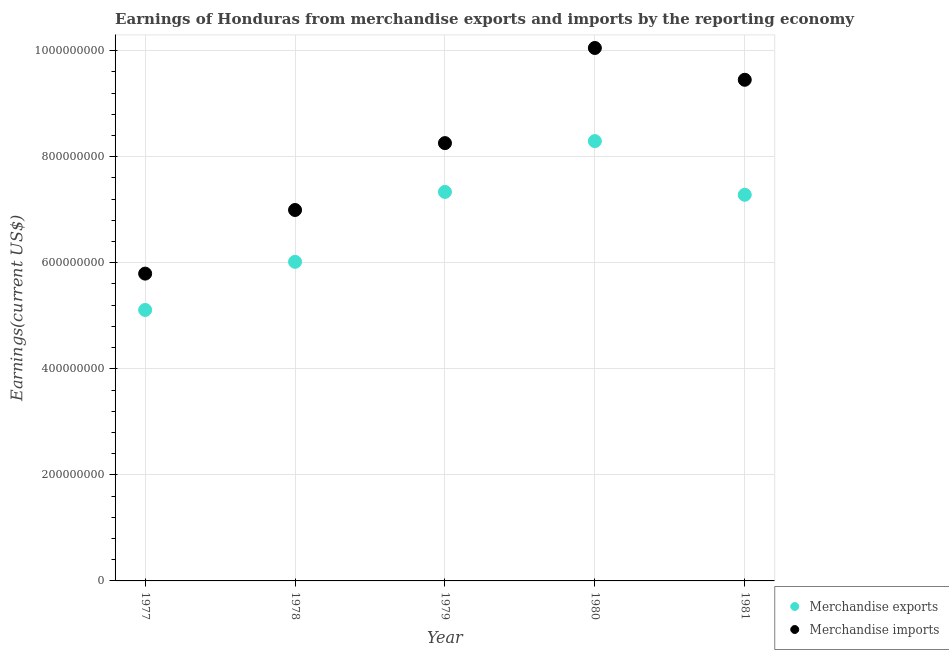Is the number of dotlines equal to the number of legend labels?
Give a very brief answer. Yes. What is the earnings from merchandise exports in 1978?
Provide a succinct answer. 6.02e+08. Across all years, what is the maximum earnings from merchandise imports?
Make the answer very short. 1.01e+09. Across all years, what is the minimum earnings from merchandise exports?
Keep it short and to the point. 5.11e+08. In which year was the earnings from merchandise imports maximum?
Offer a terse response. 1980. In which year was the earnings from merchandise exports minimum?
Your answer should be very brief. 1977. What is the total earnings from merchandise exports in the graph?
Provide a short and direct response. 3.40e+09. What is the difference between the earnings from merchandise exports in 1979 and that in 1981?
Your answer should be very brief. 5.39e+06. What is the difference between the earnings from merchandise exports in 1981 and the earnings from merchandise imports in 1980?
Provide a short and direct response. -2.77e+08. What is the average earnings from merchandise imports per year?
Make the answer very short. 8.11e+08. In the year 1981, what is the difference between the earnings from merchandise exports and earnings from merchandise imports?
Provide a short and direct response. -2.17e+08. In how many years, is the earnings from merchandise exports greater than 360000000 US$?
Make the answer very short. 5. What is the ratio of the earnings from merchandise exports in 1977 to that in 1978?
Your answer should be very brief. 0.85. Is the earnings from merchandise imports in 1980 less than that in 1981?
Provide a succinct answer. No. Is the difference between the earnings from merchandise imports in 1980 and 1981 greater than the difference between the earnings from merchandise exports in 1980 and 1981?
Your response must be concise. No. What is the difference between the highest and the second highest earnings from merchandise imports?
Provide a succinct answer. 6.00e+07. What is the difference between the highest and the lowest earnings from merchandise exports?
Your answer should be compact. 3.18e+08. In how many years, is the earnings from merchandise exports greater than the average earnings from merchandise exports taken over all years?
Offer a very short reply. 3. Is the sum of the earnings from merchandise exports in 1979 and 1980 greater than the maximum earnings from merchandise imports across all years?
Keep it short and to the point. Yes. Is the earnings from merchandise imports strictly less than the earnings from merchandise exports over the years?
Make the answer very short. No. What is the difference between two consecutive major ticks on the Y-axis?
Keep it short and to the point. 2.00e+08. Are the values on the major ticks of Y-axis written in scientific E-notation?
Make the answer very short. No. Where does the legend appear in the graph?
Provide a short and direct response. Bottom right. How many legend labels are there?
Make the answer very short. 2. How are the legend labels stacked?
Your answer should be compact. Vertical. What is the title of the graph?
Offer a terse response. Earnings of Honduras from merchandise exports and imports by the reporting economy. What is the label or title of the X-axis?
Offer a terse response. Year. What is the label or title of the Y-axis?
Provide a short and direct response. Earnings(current US$). What is the Earnings(current US$) of Merchandise exports in 1977?
Ensure brevity in your answer.  5.11e+08. What is the Earnings(current US$) in Merchandise imports in 1977?
Your response must be concise. 5.80e+08. What is the Earnings(current US$) in Merchandise exports in 1978?
Give a very brief answer. 6.02e+08. What is the Earnings(current US$) of Merchandise imports in 1978?
Make the answer very short. 7.00e+08. What is the Earnings(current US$) in Merchandise exports in 1979?
Provide a succinct answer. 7.34e+08. What is the Earnings(current US$) of Merchandise imports in 1979?
Ensure brevity in your answer.  8.26e+08. What is the Earnings(current US$) of Merchandise exports in 1980?
Your answer should be compact. 8.29e+08. What is the Earnings(current US$) in Merchandise imports in 1980?
Offer a very short reply. 1.01e+09. What is the Earnings(current US$) in Merchandise exports in 1981?
Offer a terse response. 7.28e+08. What is the Earnings(current US$) of Merchandise imports in 1981?
Make the answer very short. 9.45e+08. Across all years, what is the maximum Earnings(current US$) of Merchandise exports?
Your answer should be very brief. 8.29e+08. Across all years, what is the maximum Earnings(current US$) of Merchandise imports?
Your answer should be very brief. 1.01e+09. Across all years, what is the minimum Earnings(current US$) in Merchandise exports?
Your answer should be very brief. 5.11e+08. Across all years, what is the minimum Earnings(current US$) of Merchandise imports?
Provide a short and direct response. 5.80e+08. What is the total Earnings(current US$) of Merchandise exports in the graph?
Give a very brief answer. 3.40e+09. What is the total Earnings(current US$) in Merchandise imports in the graph?
Offer a very short reply. 4.05e+09. What is the difference between the Earnings(current US$) in Merchandise exports in 1977 and that in 1978?
Provide a short and direct response. -9.08e+07. What is the difference between the Earnings(current US$) in Merchandise imports in 1977 and that in 1978?
Ensure brevity in your answer.  -1.20e+08. What is the difference between the Earnings(current US$) in Merchandise exports in 1977 and that in 1979?
Your answer should be compact. -2.23e+08. What is the difference between the Earnings(current US$) of Merchandise imports in 1977 and that in 1979?
Provide a short and direct response. -2.46e+08. What is the difference between the Earnings(current US$) in Merchandise exports in 1977 and that in 1980?
Offer a very short reply. -3.18e+08. What is the difference between the Earnings(current US$) of Merchandise imports in 1977 and that in 1980?
Provide a short and direct response. -4.26e+08. What is the difference between the Earnings(current US$) in Merchandise exports in 1977 and that in 1981?
Make the answer very short. -2.17e+08. What is the difference between the Earnings(current US$) of Merchandise imports in 1977 and that in 1981?
Keep it short and to the point. -3.66e+08. What is the difference between the Earnings(current US$) in Merchandise exports in 1978 and that in 1979?
Offer a very short reply. -1.32e+08. What is the difference between the Earnings(current US$) in Merchandise imports in 1978 and that in 1979?
Ensure brevity in your answer.  -1.26e+08. What is the difference between the Earnings(current US$) in Merchandise exports in 1978 and that in 1980?
Provide a succinct answer. -2.28e+08. What is the difference between the Earnings(current US$) of Merchandise imports in 1978 and that in 1980?
Ensure brevity in your answer.  -3.06e+08. What is the difference between the Earnings(current US$) in Merchandise exports in 1978 and that in 1981?
Ensure brevity in your answer.  -1.26e+08. What is the difference between the Earnings(current US$) in Merchandise imports in 1978 and that in 1981?
Keep it short and to the point. -2.46e+08. What is the difference between the Earnings(current US$) of Merchandise exports in 1979 and that in 1980?
Your response must be concise. -9.58e+07. What is the difference between the Earnings(current US$) of Merchandise imports in 1979 and that in 1980?
Your answer should be very brief. -1.79e+08. What is the difference between the Earnings(current US$) in Merchandise exports in 1979 and that in 1981?
Keep it short and to the point. 5.39e+06. What is the difference between the Earnings(current US$) of Merchandise imports in 1979 and that in 1981?
Offer a very short reply. -1.19e+08. What is the difference between the Earnings(current US$) in Merchandise exports in 1980 and that in 1981?
Ensure brevity in your answer.  1.01e+08. What is the difference between the Earnings(current US$) in Merchandise imports in 1980 and that in 1981?
Make the answer very short. 6.00e+07. What is the difference between the Earnings(current US$) in Merchandise exports in 1977 and the Earnings(current US$) in Merchandise imports in 1978?
Give a very brief answer. -1.89e+08. What is the difference between the Earnings(current US$) of Merchandise exports in 1977 and the Earnings(current US$) of Merchandise imports in 1979?
Provide a short and direct response. -3.15e+08. What is the difference between the Earnings(current US$) of Merchandise exports in 1977 and the Earnings(current US$) of Merchandise imports in 1980?
Your answer should be compact. -4.94e+08. What is the difference between the Earnings(current US$) of Merchandise exports in 1977 and the Earnings(current US$) of Merchandise imports in 1981?
Provide a short and direct response. -4.34e+08. What is the difference between the Earnings(current US$) in Merchandise exports in 1978 and the Earnings(current US$) in Merchandise imports in 1979?
Offer a terse response. -2.24e+08. What is the difference between the Earnings(current US$) in Merchandise exports in 1978 and the Earnings(current US$) in Merchandise imports in 1980?
Offer a very short reply. -4.03e+08. What is the difference between the Earnings(current US$) of Merchandise exports in 1978 and the Earnings(current US$) of Merchandise imports in 1981?
Provide a short and direct response. -3.43e+08. What is the difference between the Earnings(current US$) of Merchandise exports in 1979 and the Earnings(current US$) of Merchandise imports in 1980?
Ensure brevity in your answer.  -2.71e+08. What is the difference between the Earnings(current US$) in Merchandise exports in 1979 and the Earnings(current US$) in Merchandise imports in 1981?
Your answer should be compact. -2.12e+08. What is the difference between the Earnings(current US$) of Merchandise exports in 1980 and the Earnings(current US$) of Merchandise imports in 1981?
Make the answer very short. -1.16e+08. What is the average Earnings(current US$) of Merchandise exports per year?
Your response must be concise. 6.81e+08. What is the average Earnings(current US$) of Merchandise imports per year?
Your response must be concise. 8.11e+08. In the year 1977, what is the difference between the Earnings(current US$) in Merchandise exports and Earnings(current US$) in Merchandise imports?
Provide a short and direct response. -6.85e+07. In the year 1978, what is the difference between the Earnings(current US$) of Merchandise exports and Earnings(current US$) of Merchandise imports?
Provide a succinct answer. -9.78e+07. In the year 1979, what is the difference between the Earnings(current US$) in Merchandise exports and Earnings(current US$) in Merchandise imports?
Keep it short and to the point. -9.21e+07. In the year 1980, what is the difference between the Earnings(current US$) in Merchandise exports and Earnings(current US$) in Merchandise imports?
Keep it short and to the point. -1.76e+08. In the year 1981, what is the difference between the Earnings(current US$) of Merchandise exports and Earnings(current US$) of Merchandise imports?
Offer a very short reply. -2.17e+08. What is the ratio of the Earnings(current US$) of Merchandise exports in 1977 to that in 1978?
Offer a very short reply. 0.85. What is the ratio of the Earnings(current US$) in Merchandise imports in 1977 to that in 1978?
Ensure brevity in your answer.  0.83. What is the ratio of the Earnings(current US$) in Merchandise exports in 1977 to that in 1979?
Make the answer very short. 0.7. What is the ratio of the Earnings(current US$) of Merchandise imports in 1977 to that in 1979?
Your response must be concise. 0.7. What is the ratio of the Earnings(current US$) of Merchandise exports in 1977 to that in 1980?
Provide a succinct answer. 0.62. What is the ratio of the Earnings(current US$) in Merchandise imports in 1977 to that in 1980?
Your answer should be very brief. 0.58. What is the ratio of the Earnings(current US$) in Merchandise exports in 1977 to that in 1981?
Make the answer very short. 0.7. What is the ratio of the Earnings(current US$) of Merchandise imports in 1977 to that in 1981?
Ensure brevity in your answer.  0.61. What is the ratio of the Earnings(current US$) of Merchandise exports in 1978 to that in 1979?
Your answer should be very brief. 0.82. What is the ratio of the Earnings(current US$) in Merchandise imports in 1978 to that in 1979?
Provide a short and direct response. 0.85. What is the ratio of the Earnings(current US$) of Merchandise exports in 1978 to that in 1980?
Make the answer very short. 0.73. What is the ratio of the Earnings(current US$) of Merchandise imports in 1978 to that in 1980?
Make the answer very short. 0.7. What is the ratio of the Earnings(current US$) in Merchandise exports in 1978 to that in 1981?
Offer a very short reply. 0.83. What is the ratio of the Earnings(current US$) in Merchandise imports in 1978 to that in 1981?
Your answer should be compact. 0.74. What is the ratio of the Earnings(current US$) in Merchandise exports in 1979 to that in 1980?
Keep it short and to the point. 0.88. What is the ratio of the Earnings(current US$) in Merchandise imports in 1979 to that in 1980?
Your response must be concise. 0.82. What is the ratio of the Earnings(current US$) in Merchandise exports in 1979 to that in 1981?
Your answer should be very brief. 1.01. What is the ratio of the Earnings(current US$) of Merchandise imports in 1979 to that in 1981?
Your response must be concise. 0.87. What is the ratio of the Earnings(current US$) of Merchandise exports in 1980 to that in 1981?
Your answer should be very brief. 1.14. What is the ratio of the Earnings(current US$) of Merchandise imports in 1980 to that in 1981?
Offer a terse response. 1.06. What is the difference between the highest and the second highest Earnings(current US$) of Merchandise exports?
Offer a terse response. 9.58e+07. What is the difference between the highest and the second highest Earnings(current US$) of Merchandise imports?
Give a very brief answer. 6.00e+07. What is the difference between the highest and the lowest Earnings(current US$) in Merchandise exports?
Your response must be concise. 3.18e+08. What is the difference between the highest and the lowest Earnings(current US$) in Merchandise imports?
Your response must be concise. 4.26e+08. 